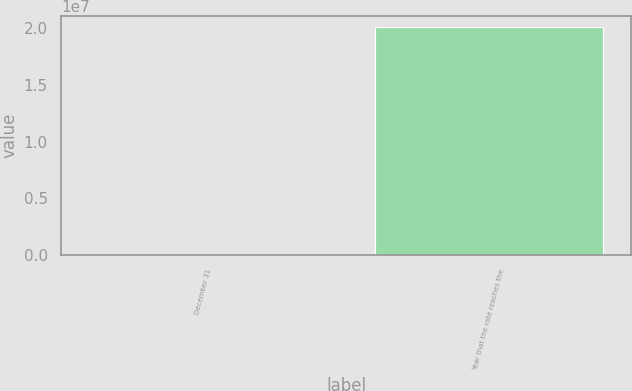Convert chart to OTSL. <chart><loc_0><loc_0><loc_500><loc_500><bar_chart><fcel>December 31<fcel>Year that the rate reaches the<nl><fcel>2007<fcel>2.0082e+07<nl></chart> 